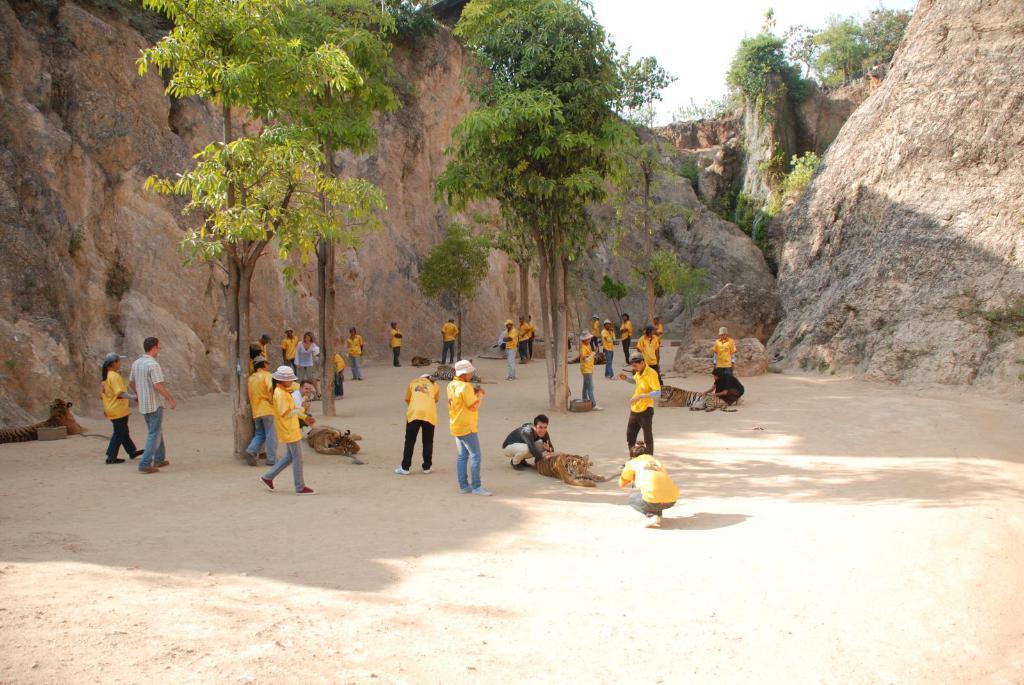How would you summarize this image in a sentence or two? In the middle of the picture, we see many people are standing. Some of them are playing with the tigers. There are trees. In the background, we see trees and the rocks. This picture might be clicked in a zoo. 